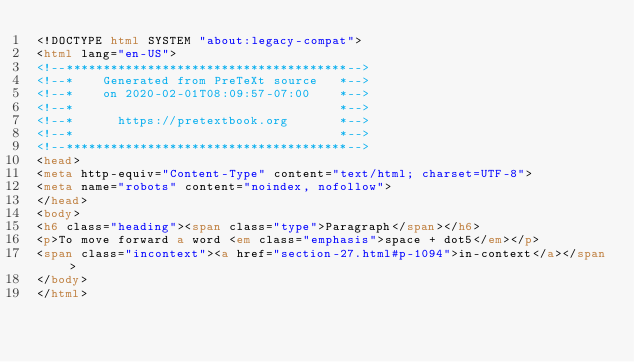Convert code to text. <code><loc_0><loc_0><loc_500><loc_500><_HTML_><!DOCTYPE html SYSTEM "about:legacy-compat">
<html lang="en-US">
<!--**************************************-->
<!--*    Generated from PreTeXt source   *-->
<!--*    on 2020-02-01T08:09:57-07:00    *-->
<!--*                                    *-->
<!--*      https://pretextbook.org       *-->
<!--*                                    *-->
<!--**************************************-->
<head>
<meta http-equiv="Content-Type" content="text/html; charset=UTF-8">
<meta name="robots" content="noindex, nofollow">
</head>
<body>
<h6 class="heading"><span class="type">Paragraph</span></h6>
<p>To move forward a word <em class="emphasis">space + dot5</em></p>
<span class="incontext"><a href="section-27.html#p-1094">in-context</a></span>
</body>
</html>
</code> 